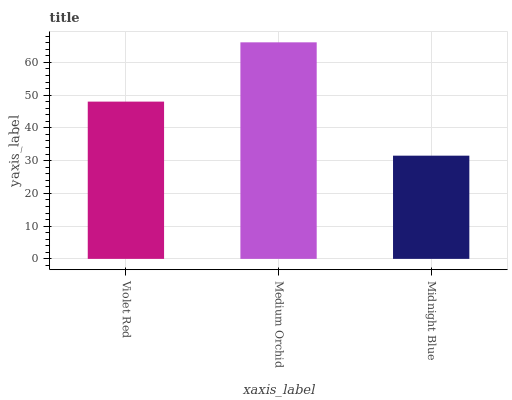Is Midnight Blue the minimum?
Answer yes or no. Yes. Is Medium Orchid the maximum?
Answer yes or no. Yes. Is Medium Orchid the minimum?
Answer yes or no. No. Is Midnight Blue the maximum?
Answer yes or no. No. Is Medium Orchid greater than Midnight Blue?
Answer yes or no. Yes. Is Midnight Blue less than Medium Orchid?
Answer yes or no. Yes. Is Midnight Blue greater than Medium Orchid?
Answer yes or no. No. Is Medium Orchid less than Midnight Blue?
Answer yes or no. No. Is Violet Red the high median?
Answer yes or no. Yes. Is Violet Red the low median?
Answer yes or no. Yes. Is Midnight Blue the high median?
Answer yes or no. No. Is Medium Orchid the low median?
Answer yes or no. No. 